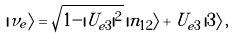Convert formula to latex. <formula><loc_0><loc_0><loc_500><loc_500>| \nu _ { e } \rangle = \sqrt { 1 - | U _ { e 3 } | ^ { 2 } } \, | n _ { 1 2 } \rangle + U _ { e 3 } \, | 3 \rangle \, ,</formula> 